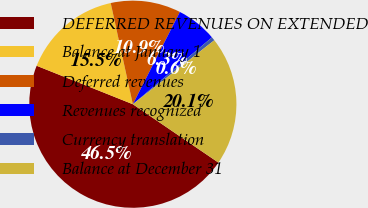Convert chart to OTSL. <chart><loc_0><loc_0><loc_500><loc_500><pie_chart><fcel>DEFERRED REVENUES ON EXTENDED<fcel>Balance at January 1<fcel>Deferred revenues<fcel>Revenues recognized<fcel>Currency translation<fcel>Balance at December 31<nl><fcel>46.53%<fcel>15.52%<fcel>10.93%<fcel>6.33%<fcel>0.57%<fcel>20.12%<nl></chart> 